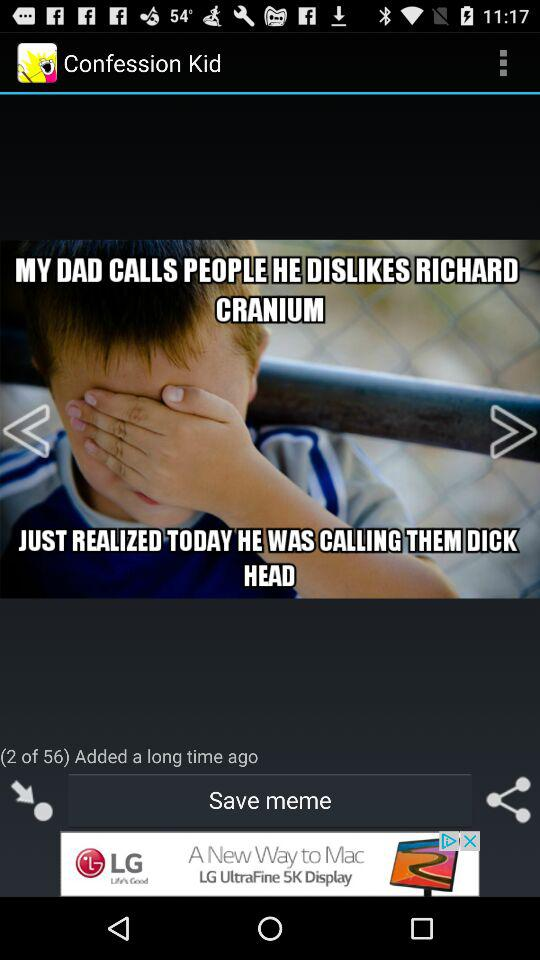Which photo number is the user on? The user is on photo number 2. 